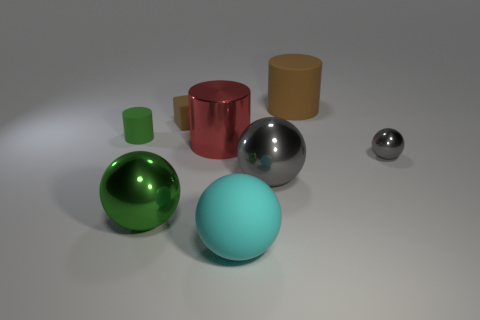Is there anything else that is the same shape as the tiny brown object?
Provide a short and direct response. No. There is a matte thing that is both behind the tiny matte cylinder and to the left of the big gray ball; what shape is it?
Your response must be concise. Cube. What is the material of the tiny object that is to the right of the sphere that is in front of the big green sphere?
Offer a terse response. Metal. Are there more gray spheres than tiny brown things?
Keep it short and to the point. Yes. Is the tiny shiny ball the same color as the small matte cylinder?
Your response must be concise. No. There is a cyan object that is the same size as the green metallic object; what is it made of?
Make the answer very short. Rubber. Are the large green ball and the large gray ball made of the same material?
Offer a terse response. Yes. How many big yellow cubes are the same material as the cyan thing?
Keep it short and to the point. 0. How many things are matte cylinders behind the green matte cylinder or tiny objects that are behind the big red thing?
Make the answer very short. 3. Are there more small things behind the tiny green cylinder than tiny rubber blocks behind the small brown rubber thing?
Provide a succinct answer. Yes. 